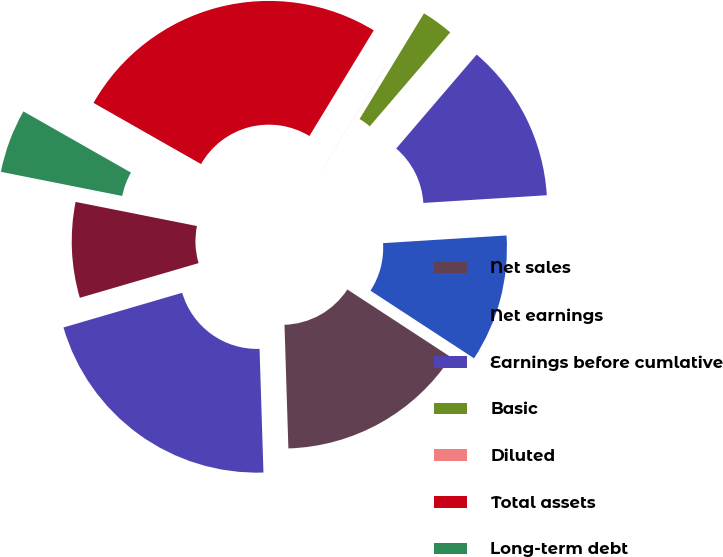Convert chart to OTSL. <chart><loc_0><loc_0><loc_500><loc_500><pie_chart><fcel>Net sales<fcel>Net earnings<fcel>Earnings before cumlative<fcel>Basic<fcel>Diluted<fcel>Total assets<fcel>Long-term debt<fcel>Other long-term obligations<fcel>Stockholders' equity<nl><fcel>15.29%<fcel>10.2%<fcel>12.74%<fcel>2.56%<fcel>0.01%<fcel>25.47%<fcel>5.11%<fcel>7.65%<fcel>20.98%<nl></chart> 